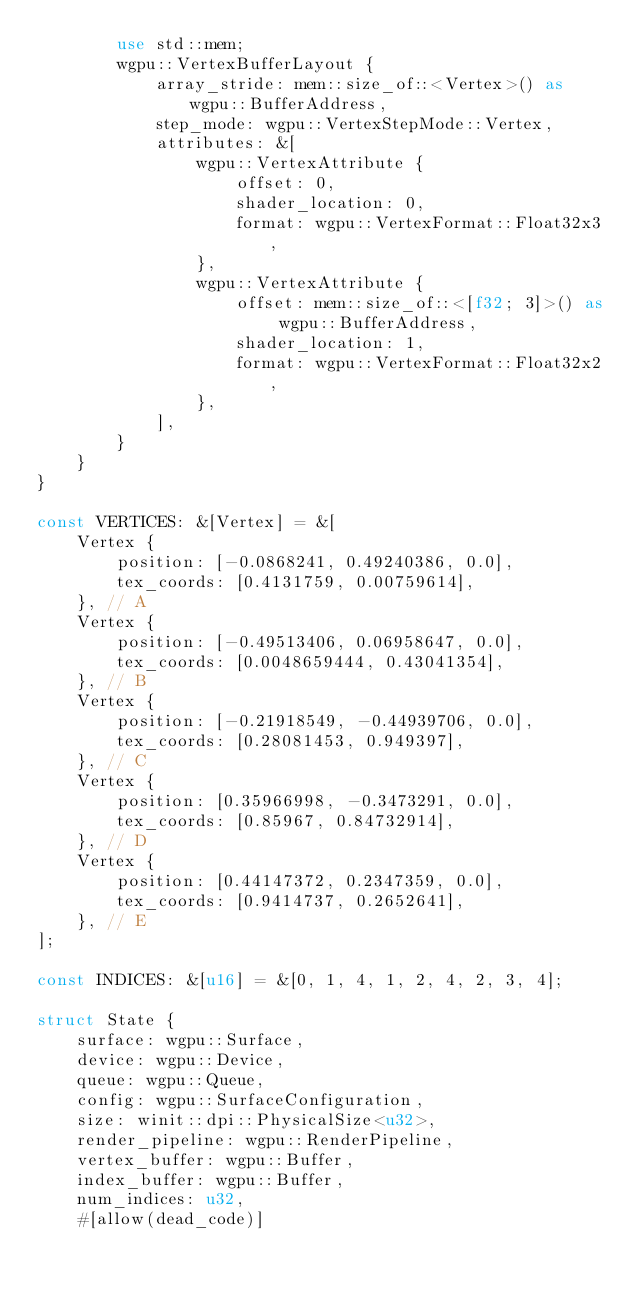Convert code to text. <code><loc_0><loc_0><loc_500><loc_500><_Rust_>        use std::mem;
        wgpu::VertexBufferLayout {
            array_stride: mem::size_of::<Vertex>() as wgpu::BufferAddress,
            step_mode: wgpu::VertexStepMode::Vertex,
            attributes: &[
                wgpu::VertexAttribute {
                    offset: 0,
                    shader_location: 0,
                    format: wgpu::VertexFormat::Float32x3,
                },
                wgpu::VertexAttribute {
                    offset: mem::size_of::<[f32; 3]>() as wgpu::BufferAddress,
                    shader_location: 1,
                    format: wgpu::VertexFormat::Float32x2,
                },
            ],
        }
    }
}

const VERTICES: &[Vertex] = &[
    Vertex {
        position: [-0.0868241, 0.49240386, 0.0],
        tex_coords: [0.4131759, 0.00759614],
    }, // A
    Vertex {
        position: [-0.49513406, 0.06958647, 0.0],
        tex_coords: [0.0048659444, 0.43041354],
    }, // B
    Vertex {
        position: [-0.21918549, -0.44939706, 0.0],
        tex_coords: [0.28081453, 0.949397],
    }, // C
    Vertex {
        position: [0.35966998, -0.3473291, 0.0],
        tex_coords: [0.85967, 0.84732914],
    }, // D
    Vertex {
        position: [0.44147372, 0.2347359, 0.0],
        tex_coords: [0.9414737, 0.2652641],
    }, // E
];

const INDICES: &[u16] = &[0, 1, 4, 1, 2, 4, 2, 3, 4];

struct State {
    surface: wgpu::Surface,
    device: wgpu::Device,
    queue: wgpu::Queue,
    config: wgpu::SurfaceConfiguration,
    size: winit::dpi::PhysicalSize<u32>,
    render_pipeline: wgpu::RenderPipeline,
    vertex_buffer: wgpu::Buffer,
    index_buffer: wgpu::Buffer,
    num_indices: u32,
    #[allow(dead_code)]</code> 